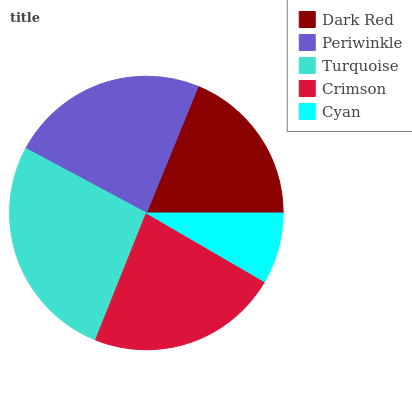Is Cyan the minimum?
Answer yes or no. Yes. Is Turquoise the maximum?
Answer yes or no. Yes. Is Periwinkle the minimum?
Answer yes or no. No. Is Periwinkle the maximum?
Answer yes or no. No. Is Periwinkle greater than Dark Red?
Answer yes or no. Yes. Is Dark Red less than Periwinkle?
Answer yes or no. Yes. Is Dark Red greater than Periwinkle?
Answer yes or no. No. Is Periwinkle less than Dark Red?
Answer yes or no. No. Is Crimson the high median?
Answer yes or no. Yes. Is Crimson the low median?
Answer yes or no. Yes. Is Dark Red the high median?
Answer yes or no. No. Is Periwinkle the low median?
Answer yes or no. No. 